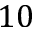Convert formula to latex. <formula><loc_0><loc_0><loc_500><loc_500>1 0</formula> 